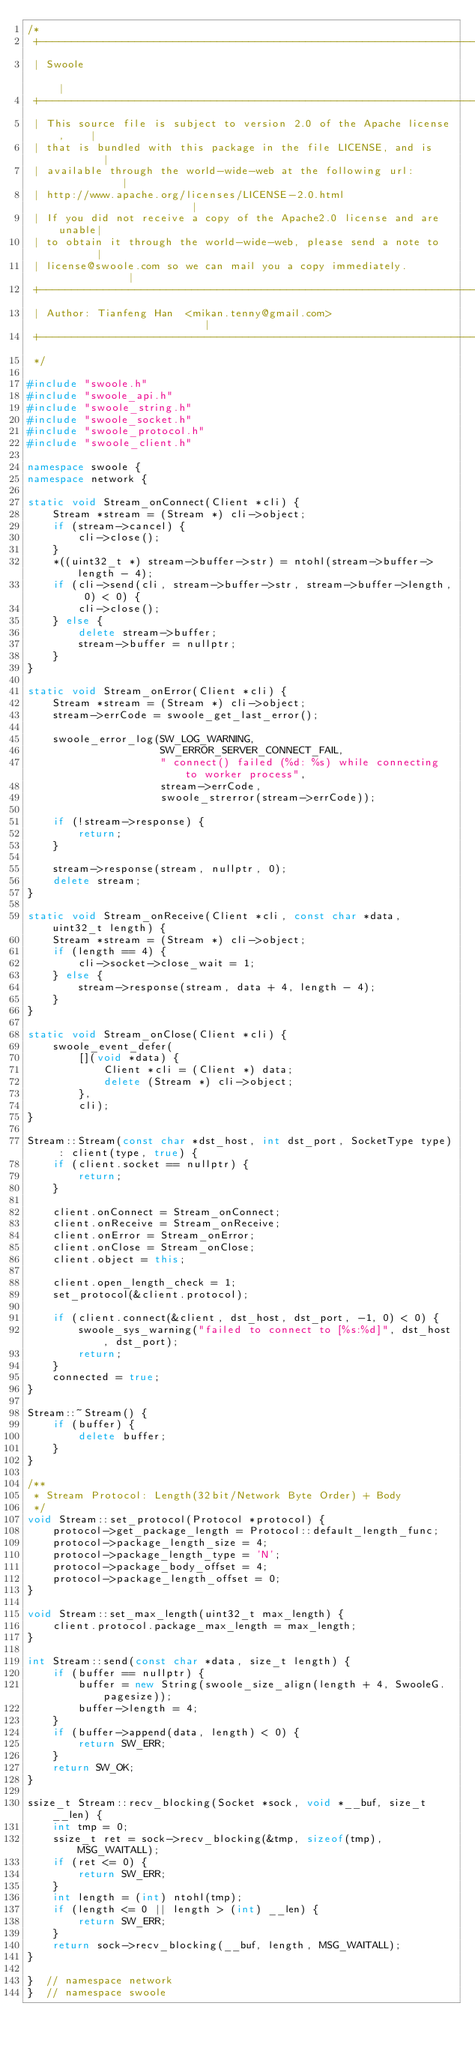Convert code to text. <code><loc_0><loc_0><loc_500><loc_500><_C++_>/*
 +----------------------------------------------------------------------+
 | Swoole                                                               |
 +----------------------------------------------------------------------+
 | This source file is subject to version 2.0 of the Apache license,    |
 | that is bundled with this package in the file LICENSE, and is        |
 | available through the world-wide-web at the following url:           |
 | http://www.apache.org/licenses/LICENSE-2.0.html                      |
 | If you did not receive a copy of the Apache2.0 license and are unable|
 | to obtain it through the world-wide-web, please send a note to       |
 | license@swoole.com so we can mail you a copy immediately.            |
 +----------------------------------------------------------------------+
 | Author: Tianfeng Han  <mikan.tenny@gmail.com>                        |
 +----------------------------------------------------------------------+
 */

#include "swoole.h"
#include "swoole_api.h"
#include "swoole_string.h"
#include "swoole_socket.h"
#include "swoole_protocol.h"
#include "swoole_client.h"

namespace swoole {
namespace network {

static void Stream_onConnect(Client *cli) {
    Stream *stream = (Stream *) cli->object;
    if (stream->cancel) {
        cli->close();
    }
    *((uint32_t *) stream->buffer->str) = ntohl(stream->buffer->length - 4);
    if (cli->send(cli, stream->buffer->str, stream->buffer->length, 0) < 0) {
        cli->close();
    } else {
        delete stream->buffer;
        stream->buffer = nullptr;
    }
}

static void Stream_onError(Client *cli) {
    Stream *stream = (Stream *) cli->object;
    stream->errCode = swoole_get_last_error();

    swoole_error_log(SW_LOG_WARNING,
                     SW_ERROR_SERVER_CONNECT_FAIL,
                     " connect() failed (%d: %s) while connecting to worker process",
                     stream->errCode,
                     swoole_strerror(stream->errCode));

    if (!stream->response) {
        return;
    }

    stream->response(stream, nullptr, 0);
    delete stream;
}

static void Stream_onReceive(Client *cli, const char *data, uint32_t length) {
    Stream *stream = (Stream *) cli->object;
    if (length == 4) {
        cli->socket->close_wait = 1;
    } else {
        stream->response(stream, data + 4, length - 4);
    }
}

static void Stream_onClose(Client *cli) {
    swoole_event_defer(
        [](void *data) {
            Client *cli = (Client *) data;
            delete (Stream *) cli->object;
        },
        cli);
}

Stream::Stream(const char *dst_host, int dst_port, SocketType type) : client(type, true) {
    if (client.socket == nullptr) {
        return;
    }

    client.onConnect = Stream_onConnect;
    client.onReceive = Stream_onReceive;
    client.onError = Stream_onError;
    client.onClose = Stream_onClose;
    client.object = this;

    client.open_length_check = 1;
    set_protocol(&client.protocol);

    if (client.connect(&client, dst_host, dst_port, -1, 0) < 0) {
        swoole_sys_warning("failed to connect to [%s:%d]", dst_host, dst_port);
        return;
    }
    connected = true;
}

Stream::~Stream() {
    if (buffer) {
        delete buffer;
    }
}

/**
 * Stream Protocol: Length(32bit/Network Byte Order) + Body
 */
void Stream::set_protocol(Protocol *protocol) {
    protocol->get_package_length = Protocol::default_length_func;
    protocol->package_length_size = 4;
    protocol->package_length_type = 'N';
    protocol->package_body_offset = 4;
    protocol->package_length_offset = 0;
}

void Stream::set_max_length(uint32_t max_length) {
    client.protocol.package_max_length = max_length;
}

int Stream::send(const char *data, size_t length) {
    if (buffer == nullptr) {
        buffer = new String(swoole_size_align(length + 4, SwooleG.pagesize));
        buffer->length = 4;
    }
    if (buffer->append(data, length) < 0) {
        return SW_ERR;
    }
    return SW_OK;
}

ssize_t Stream::recv_blocking(Socket *sock, void *__buf, size_t __len) {
    int tmp = 0;
    ssize_t ret = sock->recv_blocking(&tmp, sizeof(tmp), MSG_WAITALL);
    if (ret <= 0) {
        return SW_ERR;
    }
    int length = (int) ntohl(tmp);
    if (length <= 0 || length > (int) __len) {
        return SW_ERR;
    }
    return sock->recv_blocking(__buf, length, MSG_WAITALL);
}

}  // namespace network
}  // namespace swoole
</code> 